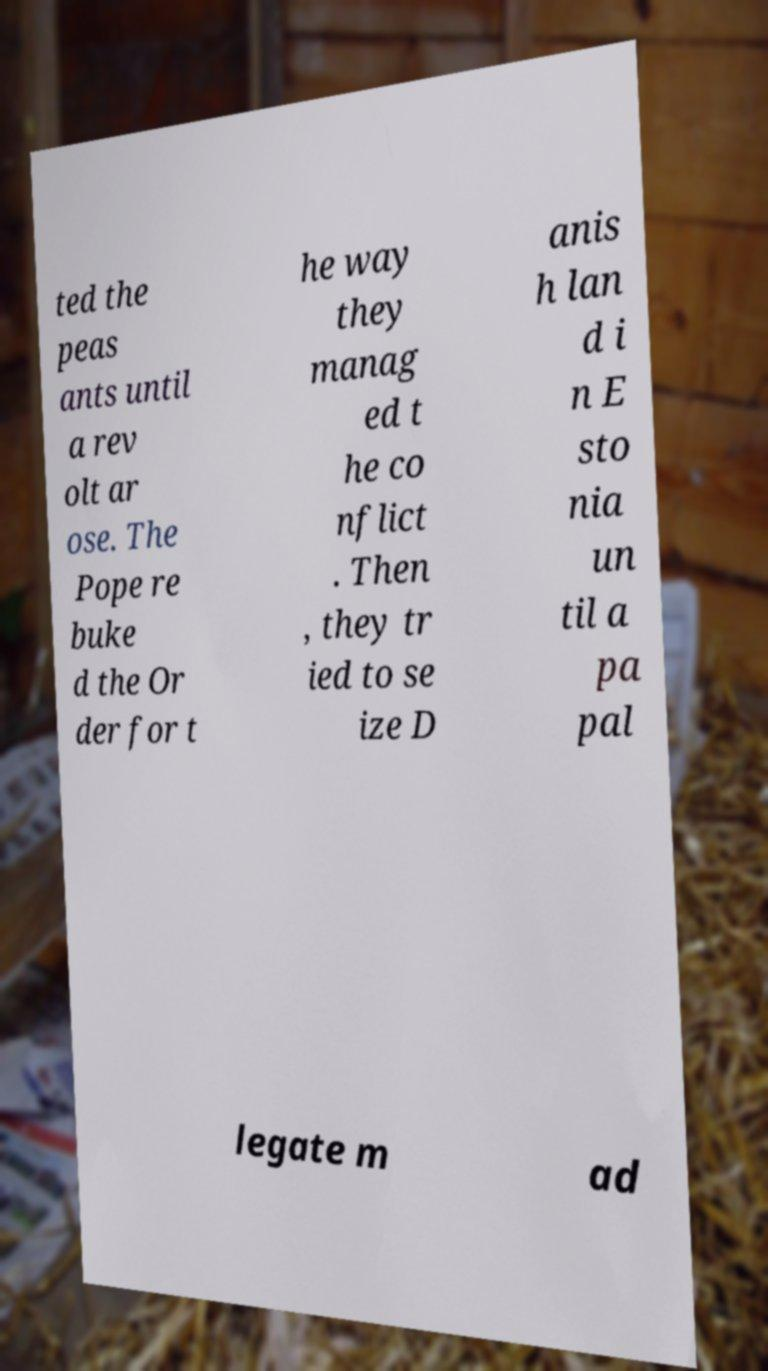For documentation purposes, I need the text within this image transcribed. Could you provide that? ted the peas ants until a rev olt ar ose. The Pope re buke d the Or der for t he way they manag ed t he co nflict . Then , they tr ied to se ize D anis h lan d i n E sto nia un til a pa pal legate m ad 